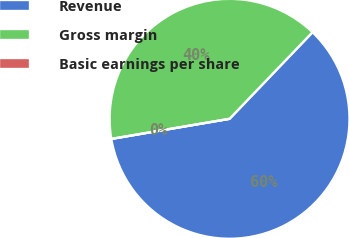Convert chart to OTSL. <chart><loc_0><loc_0><loc_500><loc_500><pie_chart><fcel>Revenue<fcel>Gross margin<fcel>Basic earnings per share<nl><fcel>60.16%<fcel>39.84%<fcel>0.0%<nl></chart> 